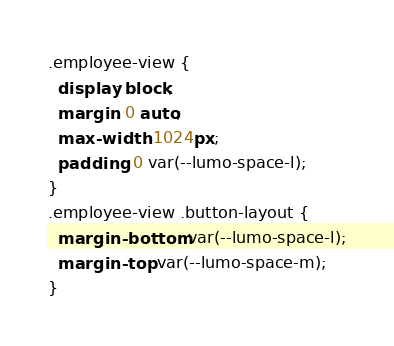<code> <loc_0><loc_0><loc_500><loc_500><_CSS_>.employee-view {
  display: block;
  margin: 0 auto;
  max-width: 1024px;
  padding: 0 var(--lumo-space-l);
}
.employee-view .button-layout {
  margin-bottom: var(--lumo-space-l);
  margin-top: var(--lumo-space-m);
}
</code> 